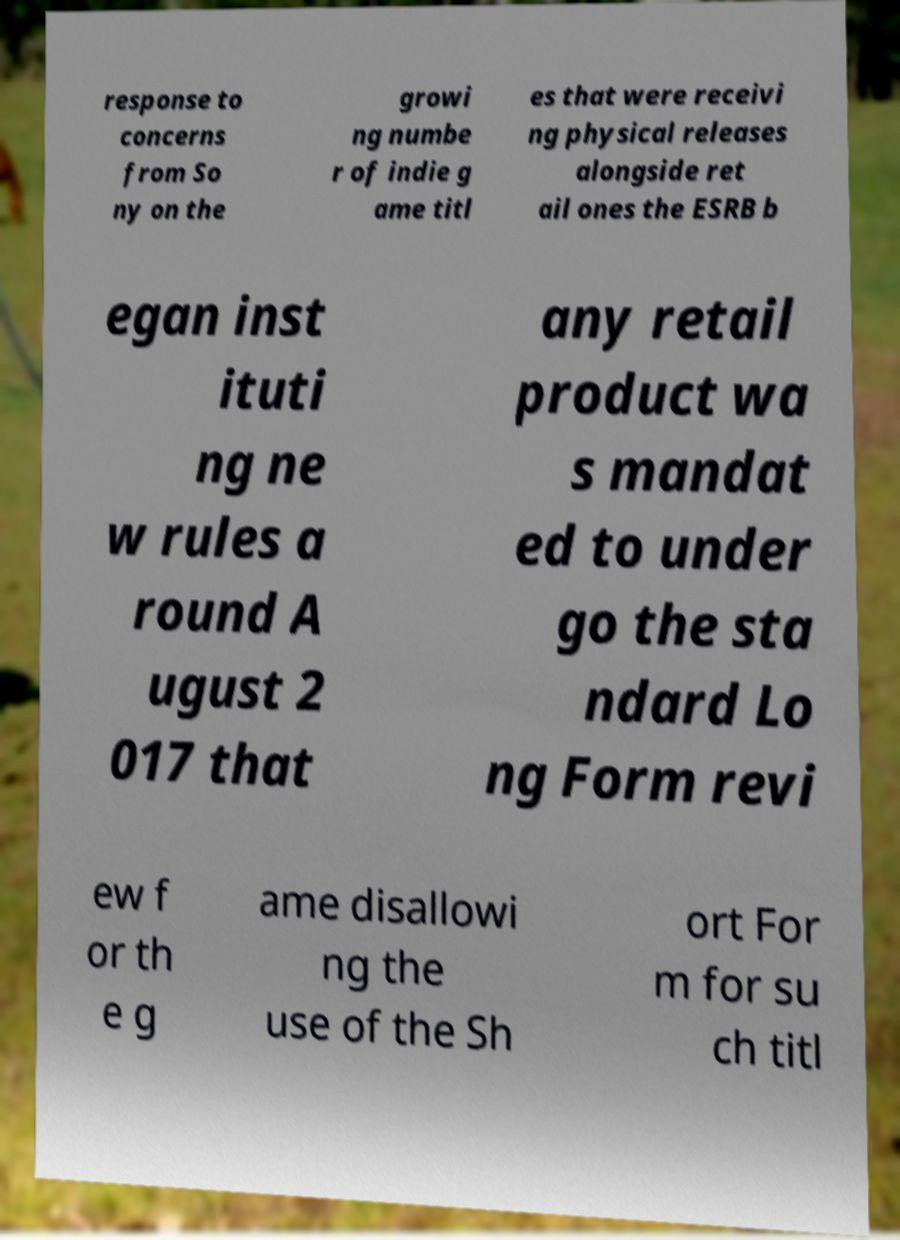What messages or text are displayed in this image? I need them in a readable, typed format. response to concerns from So ny on the growi ng numbe r of indie g ame titl es that were receivi ng physical releases alongside ret ail ones the ESRB b egan inst ituti ng ne w rules a round A ugust 2 017 that any retail product wa s mandat ed to under go the sta ndard Lo ng Form revi ew f or th e g ame disallowi ng the use of the Sh ort For m for su ch titl 